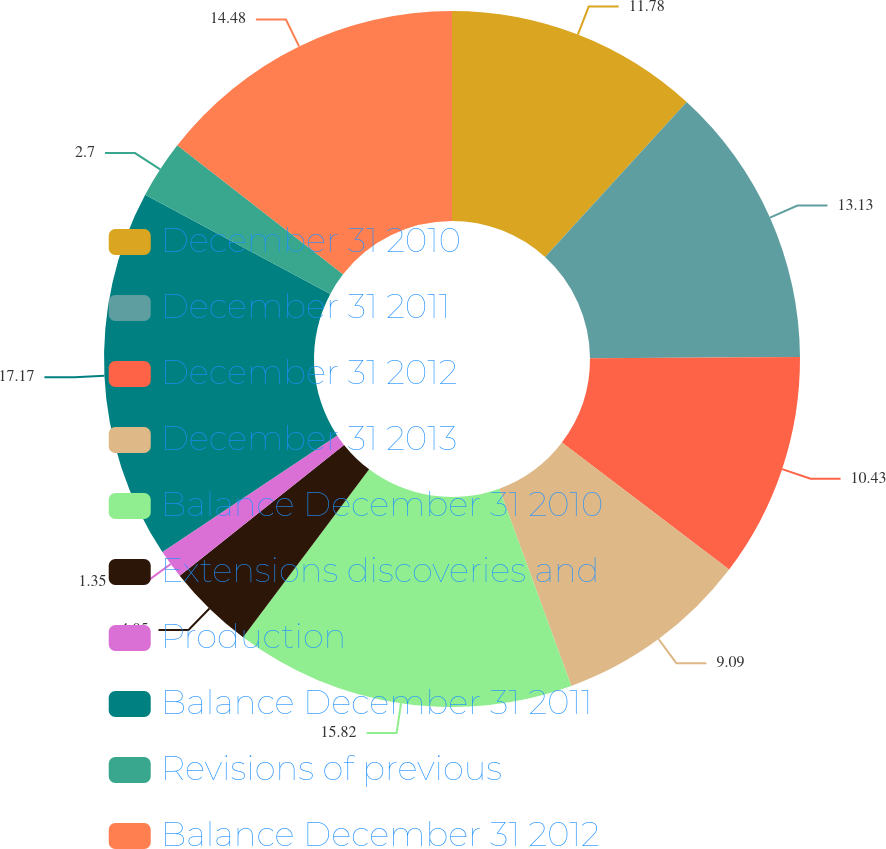Convert chart. <chart><loc_0><loc_0><loc_500><loc_500><pie_chart><fcel>December 31 2010<fcel>December 31 2011<fcel>December 31 2012<fcel>December 31 2013<fcel>Balance December 31 2010<fcel>Extensions discoveries and<fcel>Production<fcel>Balance December 31 2011<fcel>Revisions of previous<fcel>Balance December 31 2012<nl><fcel>11.78%<fcel>13.13%<fcel>10.43%<fcel>9.09%<fcel>15.82%<fcel>4.05%<fcel>1.35%<fcel>17.17%<fcel>2.7%<fcel>14.48%<nl></chart> 